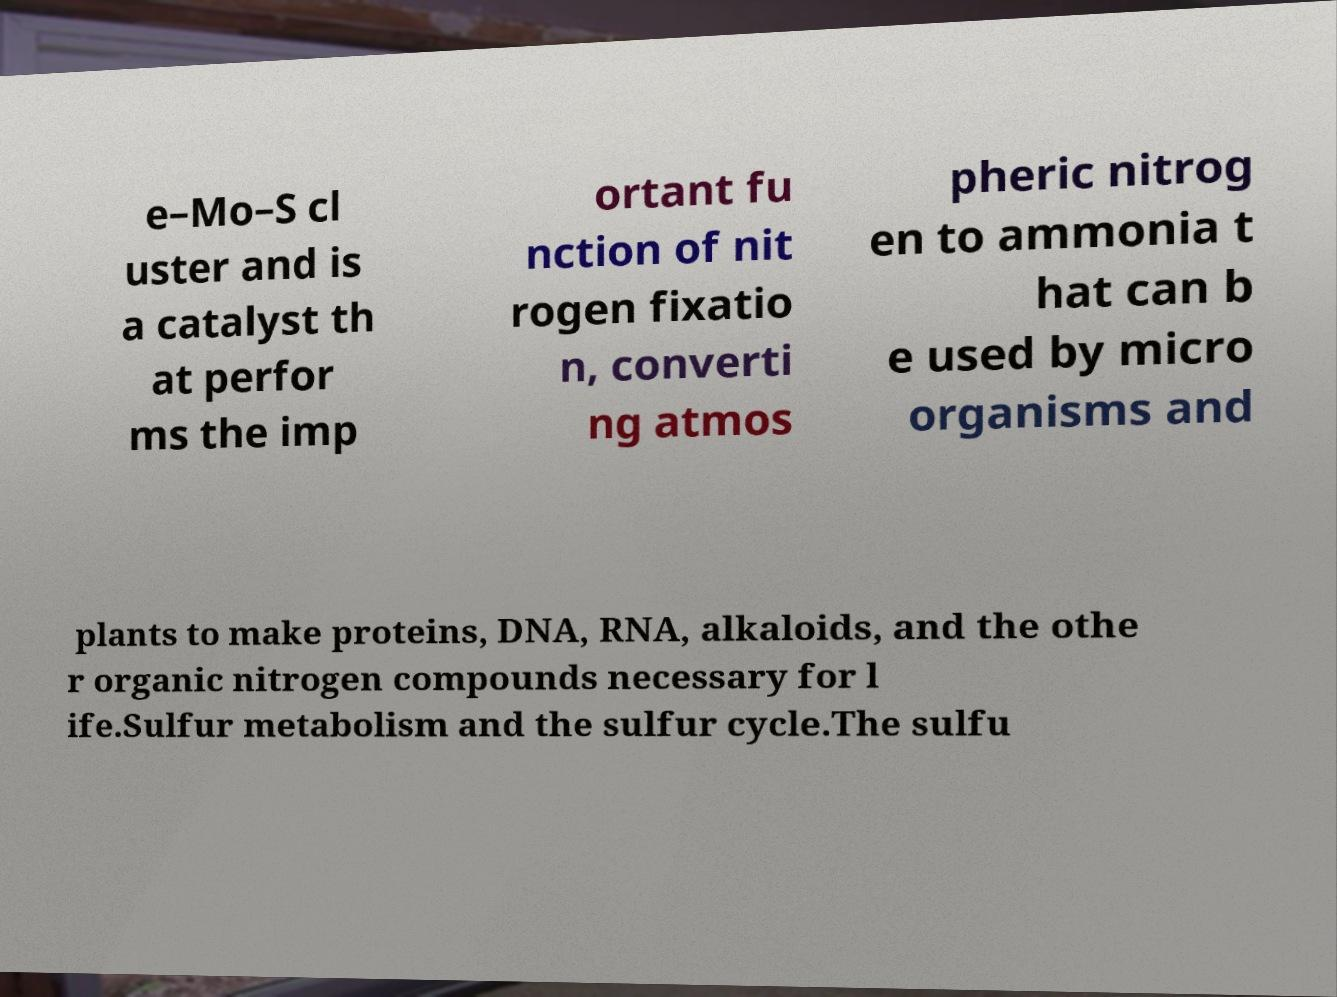There's text embedded in this image that I need extracted. Can you transcribe it verbatim? e–Mo–S cl uster and is a catalyst th at perfor ms the imp ortant fu nction of nit rogen fixatio n, converti ng atmos pheric nitrog en to ammonia t hat can b e used by micro organisms and plants to make proteins, DNA, RNA, alkaloids, and the othe r organic nitrogen compounds necessary for l ife.Sulfur metabolism and the sulfur cycle.The sulfu 